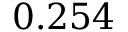<formula> <loc_0><loc_0><loc_500><loc_500>0 . 2 5 4</formula> 